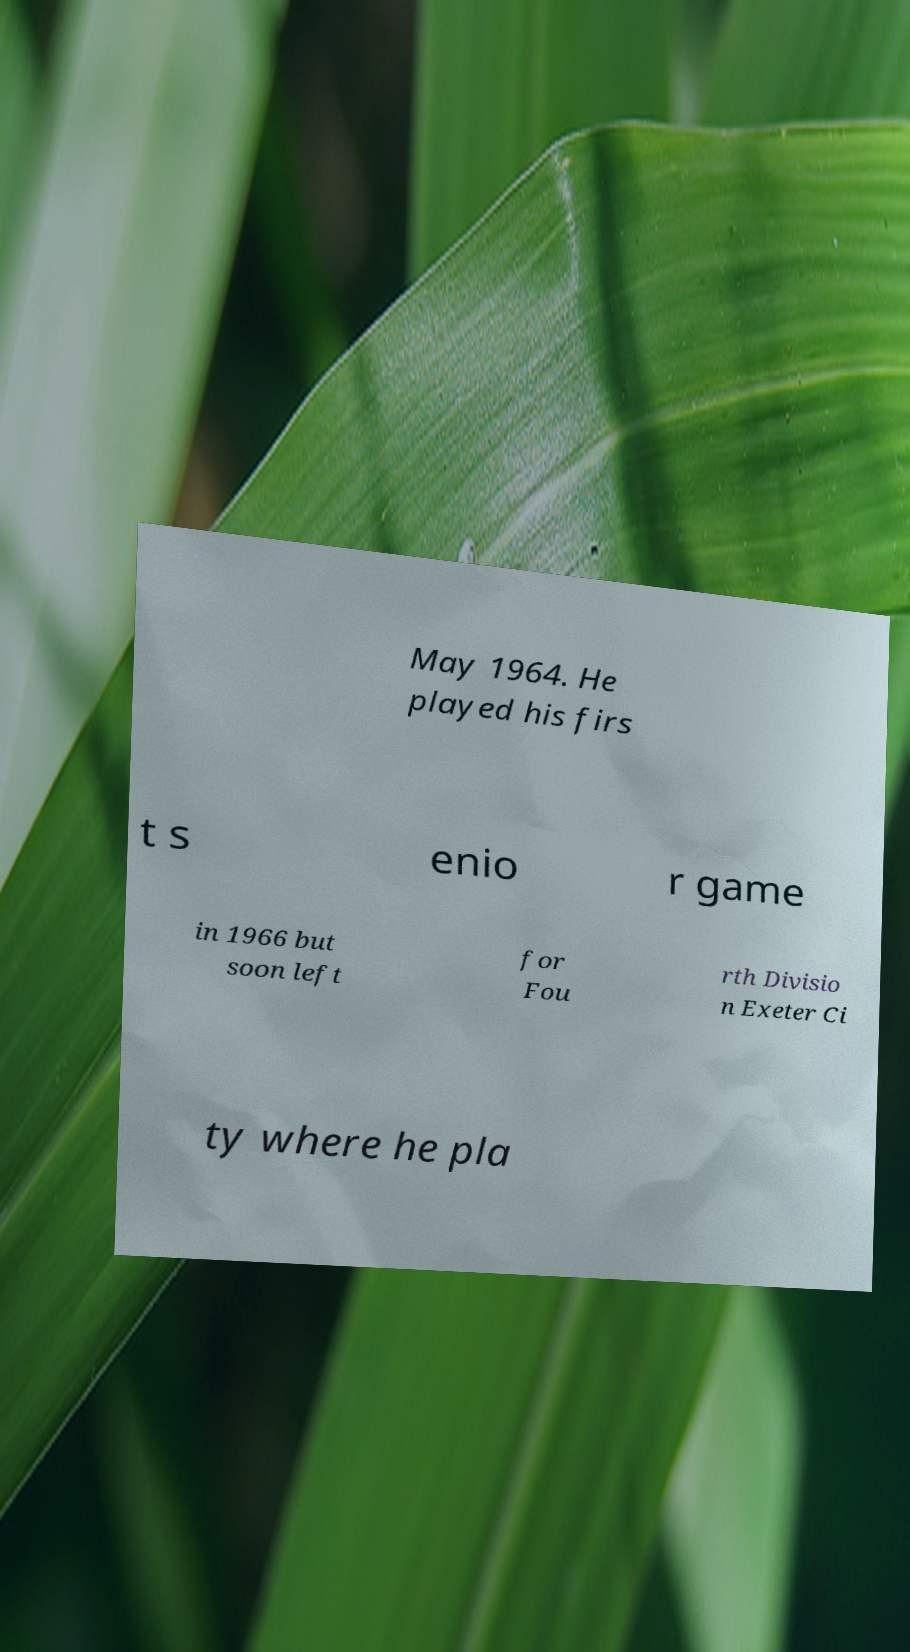Please identify and transcribe the text found in this image. May 1964. He played his firs t s enio r game in 1966 but soon left for Fou rth Divisio n Exeter Ci ty where he pla 